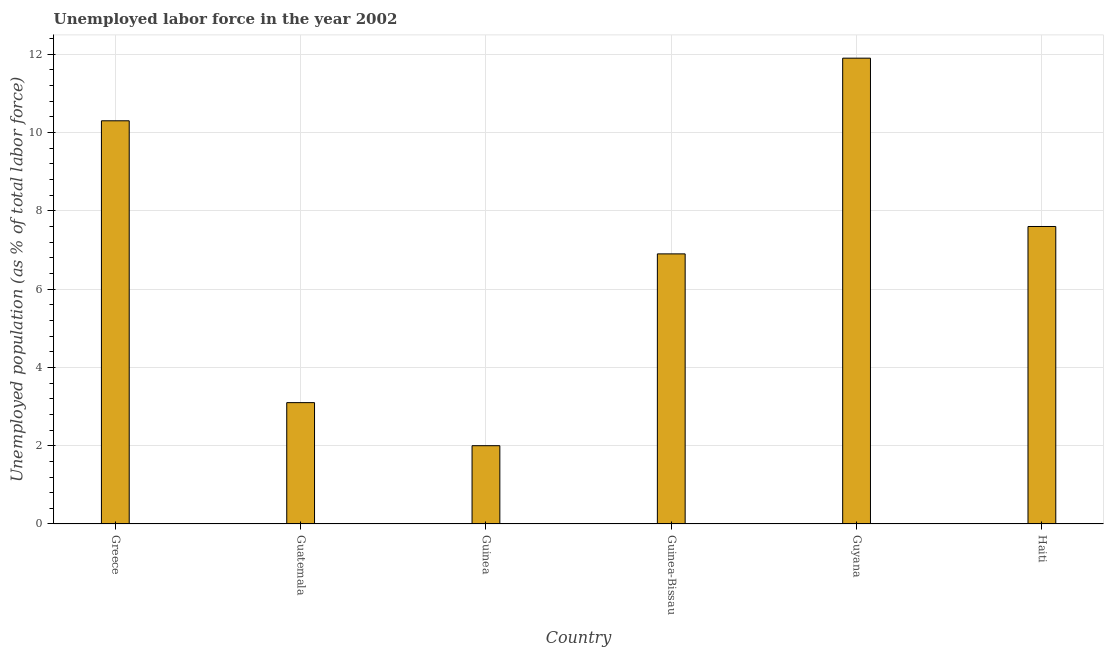Does the graph contain any zero values?
Make the answer very short. No. What is the title of the graph?
Your answer should be very brief. Unemployed labor force in the year 2002. What is the label or title of the Y-axis?
Ensure brevity in your answer.  Unemployed population (as % of total labor force). What is the total unemployed population in Greece?
Keep it short and to the point. 10.3. Across all countries, what is the maximum total unemployed population?
Provide a short and direct response. 11.9. Across all countries, what is the minimum total unemployed population?
Offer a very short reply. 2. In which country was the total unemployed population maximum?
Offer a terse response. Guyana. In which country was the total unemployed population minimum?
Provide a succinct answer. Guinea. What is the sum of the total unemployed population?
Offer a very short reply. 41.8. What is the difference between the total unemployed population in Guinea and Guinea-Bissau?
Your response must be concise. -4.9. What is the average total unemployed population per country?
Give a very brief answer. 6.97. What is the median total unemployed population?
Ensure brevity in your answer.  7.25. In how many countries, is the total unemployed population greater than 7.2 %?
Keep it short and to the point. 3. What is the ratio of the total unemployed population in Greece to that in Guinea?
Keep it short and to the point. 5.15. Is the total unemployed population in Guatemala less than that in Haiti?
Provide a short and direct response. Yes. Is the difference between the total unemployed population in Greece and Guinea greater than the difference between any two countries?
Your answer should be very brief. No. What is the difference between the highest and the second highest total unemployed population?
Keep it short and to the point. 1.6. Are all the bars in the graph horizontal?
Make the answer very short. No. What is the Unemployed population (as % of total labor force) of Greece?
Provide a succinct answer. 10.3. What is the Unemployed population (as % of total labor force) in Guatemala?
Give a very brief answer. 3.1. What is the Unemployed population (as % of total labor force) of Guinea-Bissau?
Your response must be concise. 6.9. What is the Unemployed population (as % of total labor force) of Guyana?
Provide a succinct answer. 11.9. What is the Unemployed population (as % of total labor force) in Haiti?
Provide a succinct answer. 7.6. What is the difference between the Unemployed population (as % of total labor force) in Greece and Guinea-Bissau?
Your answer should be very brief. 3.4. What is the difference between the Unemployed population (as % of total labor force) in Greece and Guyana?
Your response must be concise. -1.6. What is the difference between the Unemployed population (as % of total labor force) in Guinea and Haiti?
Provide a succinct answer. -5.6. What is the difference between the Unemployed population (as % of total labor force) in Guyana and Haiti?
Ensure brevity in your answer.  4.3. What is the ratio of the Unemployed population (as % of total labor force) in Greece to that in Guatemala?
Give a very brief answer. 3.32. What is the ratio of the Unemployed population (as % of total labor force) in Greece to that in Guinea?
Ensure brevity in your answer.  5.15. What is the ratio of the Unemployed population (as % of total labor force) in Greece to that in Guinea-Bissau?
Your answer should be very brief. 1.49. What is the ratio of the Unemployed population (as % of total labor force) in Greece to that in Guyana?
Ensure brevity in your answer.  0.87. What is the ratio of the Unemployed population (as % of total labor force) in Greece to that in Haiti?
Make the answer very short. 1.35. What is the ratio of the Unemployed population (as % of total labor force) in Guatemala to that in Guinea?
Your answer should be compact. 1.55. What is the ratio of the Unemployed population (as % of total labor force) in Guatemala to that in Guinea-Bissau?
Keep it short and to the point. 0.45. What is the ratio of the Unemployed population (as % of total labor force) in Guatemala to that in Guyana?
Offer a very short reply. 0.26. What is the ratio of the Unemployed population (as % of total labor force) in Guatemala to that in Haiti?
Offer a very short reply. 0.41. What is the ratio of the Unemployed population (as % of total labor force) in Guinea to that in Guinea-Bissau?
Your answer should be very brief. 0.29. What is the ratio of the Unemployed population (as % of total labor force) in Guinea to that in Guyana?
Your response must be concise. 0.17. What is the ratio of the Unemployed population (as % of total labor force) in Guinea to that in Haiti?
Provide a succinct answer. 0.26. What is the ratio of the Unemployed population (as % of total labor force) in Guinea-Bissau to that in Guyana?
Ensure brevity in your answer.  0.58. What is the ratio of the Unemployed population (as % of total labor force) in Guinea-Bissau to that in Haiti?
Give a very brief answer. 0.91. What is the ratio of the Unemployed population (as % of total labor force) in Guyana to that in Haiti?
Provide a short and direct response. 1.57. 